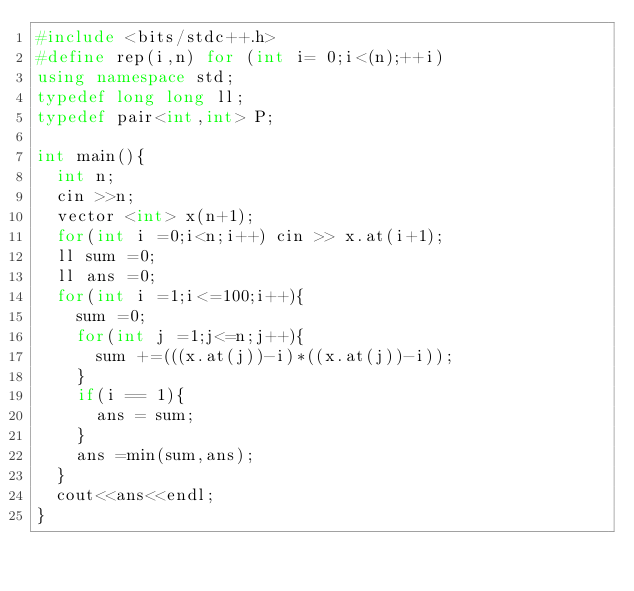<code> <loc_0><loc_0><loc_500><loc_500><_C++_>#include <bits/stdc++.h>
#define rep(i,n) for (int i= 0;i<(n);++i)
using namespace std;
typedef long long ll;
typedef pair<int,int> P;

int main(){
  int n;
  cin >>n;
  vector <int> x(n+1);
  for(int i =0;i<n;i++) cin >> x.at(i+1);
  ll sum =0;
  ll ans =0;
  for(int i =1;i<=100;i++){
    sum =0;
    for(int j =1;j<=n;j++){
      sum +=(((x.at(j))-i)*((x.at(j))-i));
    }
    if(i == 1){
      ans = sum;
    }
    ans =min(sum,ans);
  }
  cout<<ans<<endl;
}
</code> 